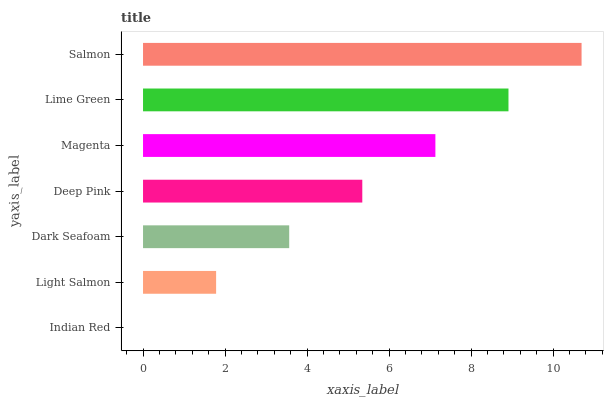Is Indian Red the minimum?
Answer yes or no. Yes. Is Salmon the maximum?
Answer yes or no. Yes. Is Light Salmon the minimum?
Answer yes or no. No. Is Light Salmon the maximum?
Answer yes or no. No. Is Light Salmon greater than Indian Red?
Answer yes or no. Yes. Is Indian Red less than Light Salmon?
Answer yes or no. Yes. Is Indian Red greater than Light Salmon?
Answer yes or no. No. Is Light Salmon less than Indian Red?
Answer yes or no. No. Is Deep Pink the high median?
Answer yes or no. Yes. Is Deep Pink the low median?
Answer yes or no. Yes. Is Magenta the high median?
Answer yes or no. No. Is Indian Red the low median?
Answer yes or no. No. 